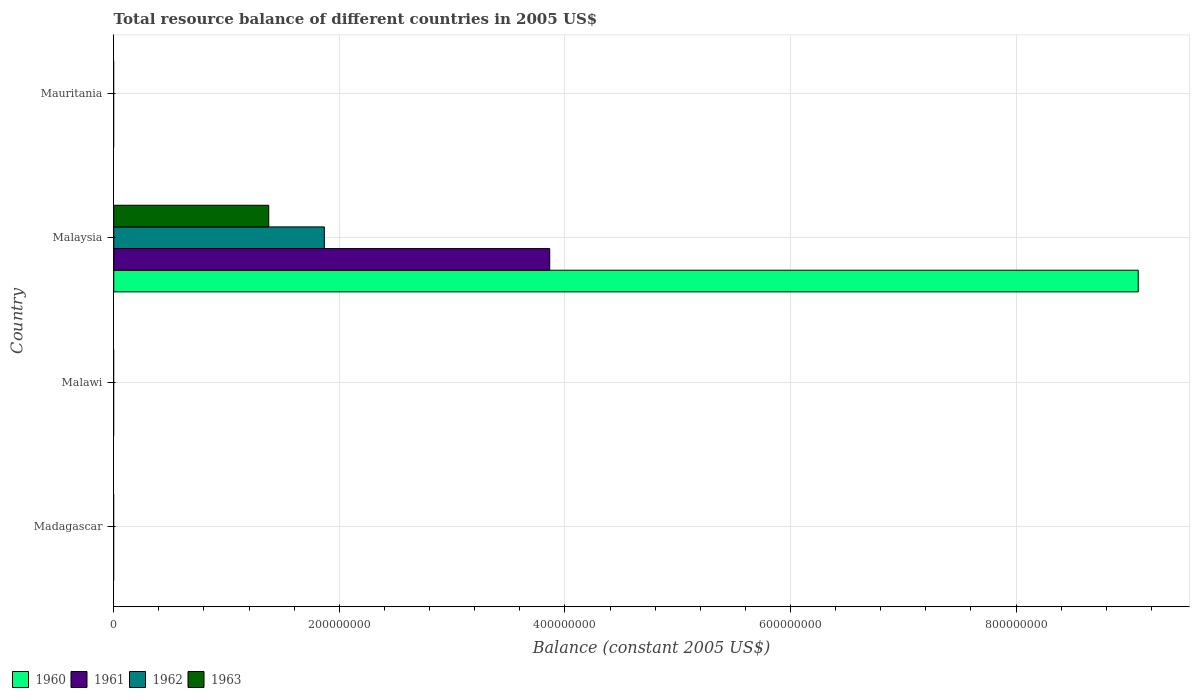Are the number of bars per tick equal to the number of legend labels?
Your answer should be compact. No. How many bars are there on the 2nd tick from the top?
Provide a short and direct response. 4. How many bars are there on the 2nd tick from the bottom?
Ensure brevity in your answer.  0. What is the label of the 2nd group of bars from the top?
Your answer should be compact. Malaysia. In how many cases, is the number of bars for a given country not equal to the number of legend labels?
Your response must be concise. 3. What is the total resource balance in 1961 in Madagascar?
Keep it short and to the point. 0. Across all countries, what is the maximum total resource balance in 1961?
Your response must be concise. 3.87e+08. Across all countries, what is the minimum total resource balance in 1960?
Give a very brief answer. 0. In which country was the total resource balance in 1962 maximum?
Make the answer very short. Malaysia. What is the total total resource balance in 1962 in the graph?
Your response must be concise. 1.87e+08. What is the difference between the total resource balance in 1961 in Mauritania and the total resource balance in 1963 in Malawi?
Your answer should be very brief. 0. What is the average total resource balance in 1961 per country?
Make the answer very short. 9.66e+07. What is the difference between the total resource balance in 1960 and total resource balance in 1962 in Malaysia?
Your response must be concise. 7.22e+08. In how many countries, is the total resource balance in 1963 greater than 880000000 US$?
Your response must be concise. 0. What is the difference between the highest and the lowest total resource balance in 1960?
Offer a very short reply. 9.08e+08. In how many countries, is the total resource balance in 1960 greater than the average total resource balance in 1960 taken over all countries?
Your answer should be very brief. 1. How many countries are there in the graph?
Your answer should be very brief. 4. What is the difference between two consecutive major ticks on the X-axis?
Give a very brief answer. 2.00e+08. Where does the legend appear in the graph?
Your answer should be compact. Bottom left. How many legend labels are there?
Your response must be concise. 4. What is the title of the graph?
Offer a very short reply. Total resource balance of different countries in 2005 US$. What is the label or title of the X-axis?
Your answer should be very brief. Balance (constant 2005 US$). What is the label or title of the Y-axis?
Offer a very short reply. Country. What is the Balance (constant 2005 US$) of 1962 in Madagascar?
Offer a terse response. 0. What is the Balance (constant 2005 US$) in 1963 in Madagascar?
Provide a succinct answer. 0. What is the Balance (constant 2005 US$) in 1963 in Malawi?
Provide a short and direct response. 0. What is the Balance (constant 2005 US$) of 1960 in Malaysia?
Your response must be concise. 9.08e+08. What is the Balance (constant 2005 US$) of 1961 in Malaysia?
Provide a short and direct response. 3.87e+08. What is the Balance (constant 2005 US$) of 1962 in Malaysia?
Make the answer very short. 1.87e+08. What is the Balance (constant 2005 US$) in 1963 in Malaysia?
Make the answer very short. 1.37e+08. What is the Balance (constant 2005 US$) in 1960 in Mauritania?
Offer a very short reply. 0. What is the Balance (constant 2005 US$) of 1961 in Mauritania?
Offer a very short reply. 0. What is the Balance (constant 2005 US$) of 1963 in Mauritania?
Give a very brief answer. 0. Across all countries, what is the maximum Balance (constant 2005 US$) of 1960?
Offer a terse response. 9.08e+08. Across all countries, what is the maximum Balance (constant 2005 US$) in 1961?
Ensure brevity in your answer.  3.87e+08. Across all countries, what is the maximum Balance (constant 2005 US$) of 1962?
Offer a very short reply. 1.87e+08. Across all countries, what is the maximum Balance (constant 2005 US$) of 1963?
Your response must be concise. 1.37e+08. Across all countries, what is the minimum Balance (constant 2005 US$) in 1961?
Give a very brief answer. 0. Across all countries, what is the minimum Balance (constant 2005 US$) in 1963?
Offer a terse response. 0. What is the total Balance (constant 2005 US$) of 1960 in the graph?
Your response must be concise. 9.08e+08. What is the total Balance (constant 2005 US$) in 1961 in the graph?
Your response must be concise. 3.87e+08. What is the total Balance (constant 2005 US$) in 1962 in the graph?
Make the answer very short. 1.87e+08. What is the total Balance (constant 2005 US$) of 1963 in the graph?
Give a very brief answer. 1.37e+08. What is the average Balance (constant 2005 US$) in 1960 per country?
Offer a terse response. 2.27e+08. What is the average Balance (constant 2005 US$) in 1961 per country?
Offer a very short reply. 9.66e+07. What is the average Balance (constant 2005 US$) of 1962 per country?
Provide a succinct answer. 4.67e+07. What is the average Balance (constant 2005 US$) in 1963 per country?
Offer a very short reply. 3.44e+07. What is the difference between the Balance (constant 2005 US$) of 1960 and Balance (constant 2005 US$) of 1961 in Malaysia?
Your response must be concise. 5.22e+08. What is the difference between the Balance (constant 2005 US$) of 1960 and Balance (constant 2005 US$) of 1962 in Malaysia?
Provide a succinct answer. 7.22e+08. What is the difference between the Balance (constant 2005 US$) of 1960 and Balance (constant 2005 US$) of 1963 in Malaysia?
Provide a short and direct response. 7.71e+08. What is the difference between the Balance (constant 2005 US$) in 1961 and Balance (constant 2005 US$) in 1962 in Malaysia?
Ensure brevity in your answer.  2.00e+08. What is the difference between the Balance (constant 2005 US$) in 1961 and Balance (constant 2005 US$) in 1963 in Malaysia?
Provide a succinct answer. 2.49e+08. What is the difference between the Balance (constant 2005 US$) of 1962 and Balance (constant 2005 US$) of 1963 in Malaysia?
Your response must be concise. 4.93e+07. What is the difference between the highest and the lowest Balance (constant 2005 US$) of 1960?
Keep it short and to the point. 9.08e+08. What is the difference between the highest and the lowest Balance (constant 2005 US$) in 1961?
Make the answer very short. 3.87e+08. What is the difference between the highest and the lowest Balance (constant 2005 US$) of 1962?
Offer a very short reply. 1.87e+08. What is the difference between the highest and the lowest Balance (constant 2005 US$) of 1963?
Offer a very short reply. 1.37e+08. 